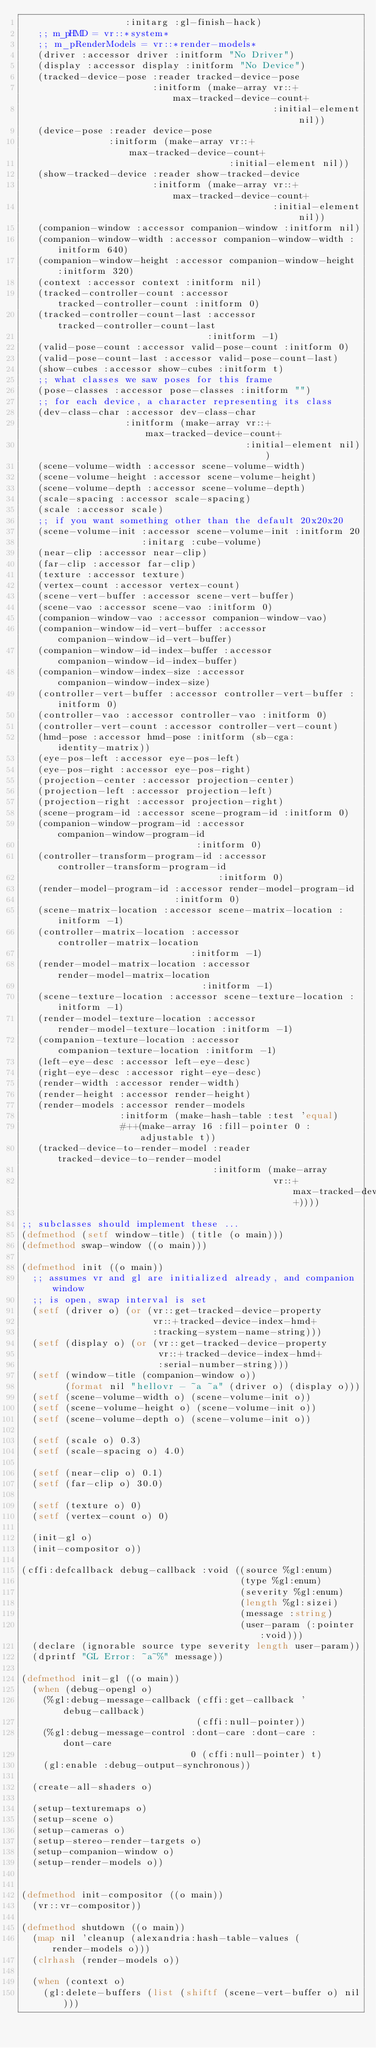<code> <loc_0><loc_0><loc_500><loc_500><_Lisp_>                   :initarg :gl-finish-hack)
   ;; m_pHMD = vr::*system*
   ;; m_pRenderModels = vr::*render-models*
   (driver :accessor driver :initform "No Driver")
   (display :accessor display :initform "No Device")
   (tracked-device-pose :reader tracked-device-pose
                        :initform (make-array vr::+max-tracked-device-count+
                                              :initial-element nil))
   (device-pose :reader device-pose
                :initform (make-array vr::+max-tracked-device-count+
                                      :initial-element nil))
   (show-tracked-device :reader show-tracked-device
                        :initform (make-array vr::+max-tracked-device-count+
                                              :initial-element nil))
   (companion-window :accessor companion-window :initform nil)
   (companion-window-width :accessor companion-window-width :initform 640)
   (companion-window-height :accessor companion-window-height :initform 320)
   (context :accessor context :initform nil)
   (tracked-controller-count :accessor tracked-controller-count :initform 0)
   (tracked-controller-count-last :accessor tracked-controller-count-last
                                  :initform -1)
   (valid-pose-count :accessor valid-pose-count :initform 0)
   (valid-pose-count-last :accessor valid-pose-count-last)
   (show-cubes :accessor show-cubes :initform t)
   ;; what classes we saw poses for this frame
   (pose-classes :accessor pose-classes :initform "")
   ;; for each device, a character representing its class
   (dev-class-char :accessor dev-class-char
                   :initform (make-array vr::+max-tracked-device-count+
                                         :initial-element nil))
   (scene-volume-width :accessor scene-volume-width)
   (scene-volume-height :accessor scene-volume-height)
   (scene-volume-depth :accessor scene-volume-depth)
   (scale-spacing :accessor scale-spacing)
   (scale :accessor scale)
   ;; if you want something other than the default 20x20x20
   (scene-volume-init :accessor scene-volume-init :initform 20
                      :initarg :cube-volume)
   (near-clip :accessor near-clip)
   (far-clip :accessor far-clip)
   (texture :accessor texture)
   (vertex-count :accessor vertex-count)
   (scene-vert-buffer :accessor scene-vert-buffer)
   (scene-vao :accessor scene-vao :initform 0)
   (companion-window-vao :accessor companion-window-vao)
   (companion-window-id-vert-buffer :accessor companion-window-id-vert-buffer)
   (companion-window-id-index-buffer :accessor companion-window-id-index-buffer)
   (companion-window-index-size :accessor companion-window-index-size)
   (controller-vert-buffer :accessor controller-vert-buffer :initform 0)
   (controller-vao :accessor controller-vao :initform 0)
   (controller-vert-count :accessor controller-vert-count)
   (hmd-pose :accessor hmd-pose :initform (sb-cga:identity-matrix))
   (eye-pos-left :accessor eye-pos-left)
   (eye-pos-right :accessor eye-pos-right)
   (projection-center :accessor projection-center)
   (projection-left :accessor projection-left)
   (projection-right :accessor projection-right)
   (scene-program-id :accessor scene-program-id :initform 0)
   (companion-window-program-id :accessor companion-window-program-id
                                :initform 0)
   (controller-transform-program-id :accessor controller-transform-program-id
                                    :initform 0)
   (render-model-program-id :accessor render-model-program-id
                            :initform 0)
   (scene-matrix-location :accessor scene-matrix-location :initform -1)
   (controller-matrix-location :accessor controller-matrix-location
                               :initform -1)
   (render-model-matrix-location :accessor render-model-matrix-location
                                 :initform -1)
   (scene-texture-location :accessor scene-texture-location :initform -1)
   (render-model-texture-location :accessor render-model-texture-location :initform -1)
   (companion-texture-location :accessor companion-texture-location :initform -1)
   (left-eye-desc :accessor left-eye-desc)
   (right-eye-desc :accessor right-eye-desc)
   (render-width :accessor render-width)
   (render-height :accessor render-height)
   (render-models :accessor render-models
                  :initform (make-hash-table :test 'equal)
                  #++(make-array 16 :fill-pointer 0 :adjustable t))
   (tracked-device-to-render-model :reader tracked-device-to-render-model
                                   :initform (make-array
                                              vr::+max-tracked-device-count+))))

;; subclasses should implement these ...
(defmethod (setf window-title) (title (o main)))
(defmethod swap-window ((o main)))

(defmethod init ((o main))
  ;; assumes vr and gl are initialized already, and companion window
  ;; is open, swap interval is set
  (setf (driver o) (or (vr::get-tracked-device-property
                        vr::+tracked-device-index-hmd+
                        :tracking-system-name-string)))
  (setf (display o) (or (vr::get-tracked-device-property
                         vr::+tracked-device-index-hmd+
                         :serial-number-string)))
  (setf (window-title (companion-window o))
        (format nil "hellovr - ~a ~a" (driver o) (display o)))
  (setf (scene-volume-width o) (scene-volume-init o))
  (setf (scene-volume-height o) (scene-volume-init o))
  (setf (scene-volume-depth o) (scene-volume-init o))

  (setf (scale o) 0.3)
  (setf (scale-spacing o) 4.0)

  (setf (near-clip o) 0.1)
  (setf (far-clip o) 30.0)

  (setf (texture o) 0)
  (setf (vertex-count o) 0)

  (init-gl o)
  (init-compositor o))

(cffi:defcallback debug-callback :void ((source %gl:enum)
                                        (type %gl:enum)
                                        (severity %gl:enum)
                                        (length %gl:sizei)
                                        (message :string)
                                        (user-param (:pointer :void)))
  (declare (ignorable source type severity length user-param))
  (dprintf "GL Error: ~a~%" message))

(defmethod init-gl ((o main))
  (when (debug-opengl o)
    (%gl:debug-message-callback (cffi:get-callback 'debug-callback)
                                (cffi:null-pointer))
    (%gl:debug-message-control :dont-care :dont-care :dont-care
                               0 (cffi:null-pointer) t)
    (gl:enable :debug-output-synchronous))

  (create-all-shaders o)

  (setup-texturemaps o)
  (setup-scene o)
  (setup-cameras o)
  (setup-stereo-render-targets o)
  (setup-companion-window o)
  (setup-render-models o))


(defmethod init-compositor ((o main))
  (vr::vr-compositor))

(defmethod shutdown ((o main))
  (map nil 'cleanup (alexandria:hash-table-values (render-models o)))
  (clrhash (render-models o))

  (when (context o)
    (gl:delete-buffers (list (shiftf (scene-vert-buffer o) nil)))</code> 